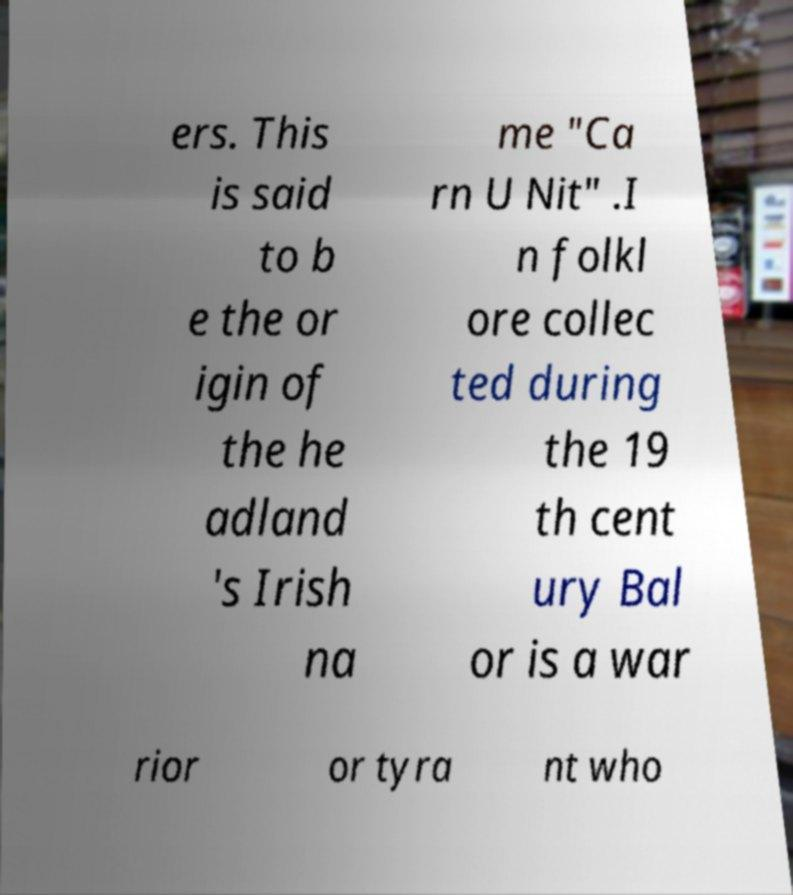Can you accurately transcribe the text from the provided image for me? ers. This is said to b e the or igin of the he adland 's Irish na me "Ca rn U Nit" .I n folkl ore collec ted during the 19 th cent ury Bal or is a war rior or tyra nt who 